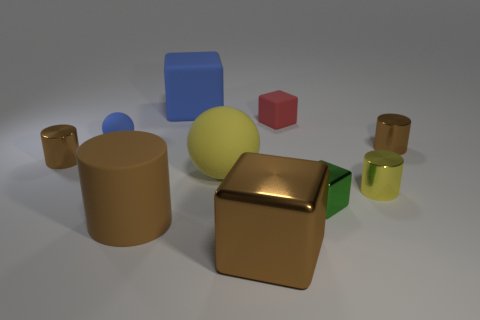Is there a large cyan thing of the same shape as the tiny blue thing?
Your answer should be very brief. No. What number of objects are brown balls or big blue rubber blocks left of the small red rubber cube?
Offer a very short reply. 1. The metallic cylinder that is left of the big brown cube is what color?
Provide a succinct answer. Brown. Is the size of the cylinder in front of the yellow cylinder the same as the brown metallic thing that is on the left side of the large rubber block?
Keep it short and to the point. No. Is there a matte object of the same size as the yellow metallic thing?
Provide a short and direct response. Yes. What number of tiny metallic cylinders are right of the metal cylinder on the left side of the large brown matte cylinder?
Give a very brief answer. 2. What material is the small red cube?
Offer a very short reply. Rubber. There is a brown matte cylinder; how many large blue things are in front of it?
Ensure brevity in your answer.  0. Do the large metal object and the large matte cylinder have the same color?
Ensure brevity in your answer.  Yes. What number of small rubber objects have the same color as the big matte cube?
Keep it short and to the point. 1. 